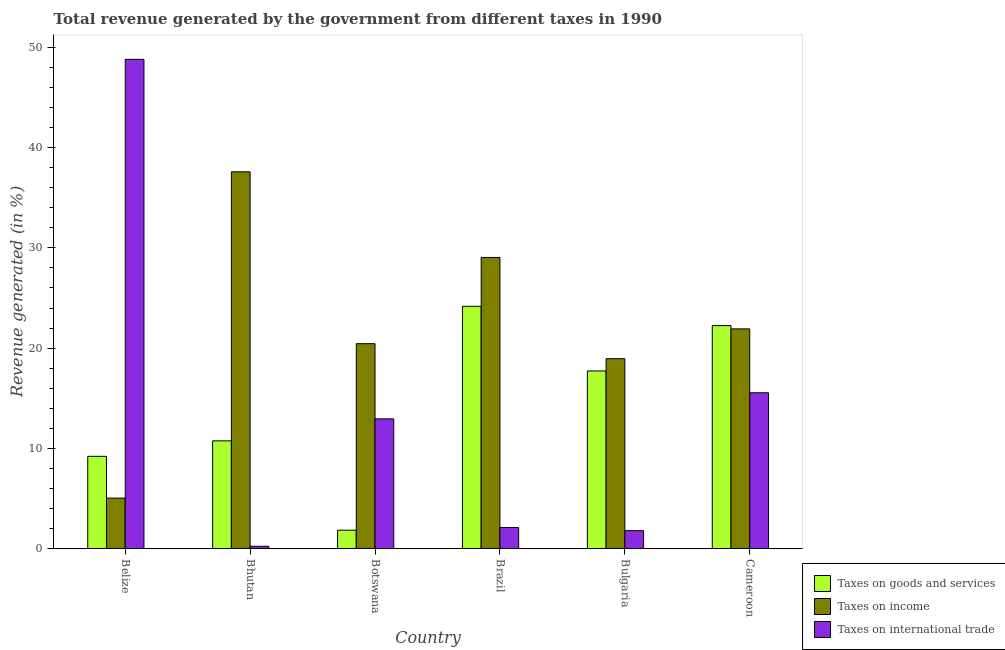How many groups of bars are there?
Offer a terse response. 6. Are the number of bars per tick equal to the number of legend labels?
Your answer should be very brief. Yes. Are the number of bars on each tick of the X-axis equal?
Keep it short and to the point. Yes. How many bars are there on the 2nd tick from the right?
Provide a short and direct response. 3. What is the label of the 4th group of bars from the left?
Provide a short and direct response. Brazil. What is the percentage of revenue generated by taxes on goods and services in Bhutan?
Give a very brief answer. 10.74. Across all countries, what is the maximum percentage of revenue generated by taxes on goods and services?
Offer a very short reply. 24.17. Across all countries, what is the minimum percentage of revenue generated by tax on international trade?
Make the answer very short. 0.22. In which country was the percentage of revenue generated by taxes on income minimum?
Offer a terse response. Belize. What is the total percentage of revenue generated by taxes on goods and services in the graph?
Give a very brief answer. 85.9. What is the difference between the percentage of revenue generated by taxes on income in Bhutan and that in Bulgaria?
Provide a short and direct response. 18.65. What is the difference between the percentage of revenue generated by taxes on income in Belize and the percentage of revenue generated by tax on international trade in Bhutan?
Offer a terse response. 4.81. What is the average percentage of revenue generated by taxes on income per country?
Provide a short and direct response. 22.16. What is the difference between the percentage of revenue generated by tax on international trade and percentage of revenue generated by taxes on goods and services in Botswana?
Keep it short and to the point. 11.11. In how many countries, is the percentage of revenue generated by taxes on income greater than 14 %?
Make the answer very short. 5. What is the ratio of the percentage of revenue generated by taxes on goods and services in Belize to that in Brazil?
Your response must be concise. 0.38. Is the percentage of revenue generated by tax on international trade in Belize less than that in Botswana?
Provide a succinct answer. No. What is the difference between the highest and the second highest percentage of revenue generated by taxes on income?
Provide a short and direct response. 8.55. What is the difference between the highest and the lowest percentage of revenue generated by tax on international trade?
Offer a terse response. 48.6. In how many countries, is the percentage of revenue generated by tax on international trade greater than the average percentage of revenue generated by tax on international trade taken over all countries?
Keep it short and to the point. 2. Is the sum of the percentage of revenue generated by taxes on income in Botswana and Cameroon greater than the maximum percentage of revenue generated by taxes on goods and services across all countries?
Offer a terse response. Yes. What does the 3rd bar from the left in Bhutan represents?
Keep it short and to the point. Taxes on international trade. What does the 2nd bar from the right in Botswana represents?
Make the answer very short. Taxes on income. Is it the case that in every country, the sum of the percentage of revenue generated by taxes on goods and services and percentage of revenue generated by taxes on income is greater than the percentage of revenue generated by tax on international trade?
Give a very brief answer. No. Are all the bars in the graph horizontal?
Your answer should be compact. No. How many countries are there in the graph?
Keep it short and to the point. 6. What is the difference between two consecutive major ticks on the Y-axis?
Offer a terse response. 10. Are the values on the major ticks of Y-axis written in scientific E-notation?
Your answer should be compact. No. Does the graph contain any zero values?
Make the answer very short. No. Does the graph contain grids?
Provide a short and direct response. No. Where does the legend appear in the graph?
Offer a terse response. Bottom right. What is the title of the graph?
Offer a very short reply. Total revenue generated by the government from different taxes in 1990. What is the label or title of the Y-axis?
Your response must be concise. Revenue generated (in %). What is the Revenue generated (in %) of Taxes on goods and services in Belize?
Keep it short and to the point. 9.2. What is the Revenue generated (in %) of Taxes on income in Belize?
Make the answer very short. 5.03. What is the Revenue generated (in %) of Taxes on international trade in Belize?
Your response must be concise. 48.82. What is the Revenue generated (in %) of Taxes on goods and services in Bhutan?
Offer a terse response. 10.74. What is the Revenue generated (in %) in Taxes on income in Bhutan?
Offer a very short reply. 37.59. What is the Revenue generated (in %) in Taxes on international trade in Bhutan?
Your answer should be compact. 0.22. What is the Revenue generated (in %) in Taxes on goods and services in Botswana?
Provide a succinct answer. 1.82. What is the Revenue generated (in %) of Taxes on income in Botswana?
Keep it short and to the point. 20.44. What is the Revenue generated (in %) of Taxes on international trade in Botswana?
Offer a terse response. 12.94. What is the Revenue generated (in %) of Taxes on goods and services in Brazil?
Offer a very short reply. 24.17. What is the Revenue generated (in %) in Taxes on income in Brazil?
Your answer should be compact. 29.05. What is the Revenue generated (in %) of Taxes on international trade in Brazil?
Make the answer very short. 2.09. What is the Revenue generated (in %) in Taxes on goods and services in Bulgaria?
Give a very brief answer. 17.72. What is the Revenue generated (in %) of Taxes on income in Bulgaria?
Ensure brevity in your answer.  18.94. What is the Revenue generated (in %) of Taxes on international trade in Bulgaria?
Give a very brief answer. 1.78. What is the Revenue generated (in %) of Taxes on goods and services in Cameroon?
Offer a terse response. 22.24. What is the Revenue generated (in %) of Taxes on income in Cameroon?
Make the answer very short. 21.92. What is the Revenue generated (in %) of Taxes on international trade in Cameroon?
Offer a terse response. 15.54. Across all countries, what is the maximum Revenue generated (in %) of Taxes on goods and services?
Your answer should be compact. 24.17. Across all countries, what is the maximum Revenue generated (in %) of Taxes on income?
Give a very brief answer. 37.59. Across all countries, what is the maximum Revenue generated (in %) of Taxes on international trade?
Give a very brief answer. 48.82. Across all countries, what is the minimum Revenue generated (in %) in Taxes on goods and services?
Ensure brevity in your answer.  1.82. Across all countries, what is the minimum Revenue generated (in %) of Taxes on income?
Provide a succinct answer. 5.03. Across all countries, what is the minimum Revenue generated (in %) in Taxes on international trade?
Make the answer very short. 0.22. What is the total Revenue generated (in %) of Taxes on goods and services in the graph?
Your response must be concise. 85.9. What is the total Revenue generated (in %) in Taxes on income in the graph?
Your answer should be compact. 132.97. What is the total Revenue generated (in %) in Taxes on international trade in the graph?
Offer a terse response. 81.39. What is the difference between the Revenue generated (in %) in Taxes on goods and services in Belize and that in Bhutan?
Give a very brief answer. -1.55. What is the difference between the Revenue generated (in %) in Taxes on income in Belize and that in Bhutan?
Your answer should be compact. -32.56. What is the difference between the Revenue generated (in %) of Taxes on international trade in Belize and that in Bhutan?
Your response must be concise. 48.6. What is the difference between the Revenue generated (in %) in Taxes on goods and services in Belize and that in Botswana?
Keep it short and to the point. 7.37. What is the difference between the Revenue generated (in %) in Taxes on income in Belize and that in Botswana?
Offer a very short reply. -15.41. What is the difference between the Revenue generated (in %) of Taxes on international trade in Belize and that in Botswana?
Give a very brief answer. 35.88. What is the difference between the Revenue generated (in %) of Taxes on goods and services in Belize and that in Brazil?
Offer a terse response. -14.97. What is the difference between the Revenue generated (in %) of Taxes on income in Belize and that in Brazil?
Keep it short and to the point. -24.02. What is the difference between the Revenue generated (in %) of Taxes on international trade in Belize and that in Brazil?
Your answer should be very brief. 46.73. What is the difference between the Revenue generated (in %) of Taxes on goods and services in Belize and that in Bulgaria?
Make the answer very short. -8.52. What is the difference between the Revenue generated (in %) of Taxes on income in Belize and that in Bulgaria?
Keep it short and to the point. -13.92. What is the difference between the Revenue generated (in %) in Taxes on international trade in Belize and that in Bulgaria?
Offer a terse response. 47.04. What is the difference between the Revenue generated (in %) in Taxes on goods and services in Belize and that in Cameroon?
Keep it short and to the point. -13.05. What is the difference between the Revenue generated (in %) in Taxes on income in Belize and that in Cameroon?
Your answer should be compact. -16.89. What is the difference between the Revenue generated (in %) of Taxes on international trade in Belize and that in Cameroon?
Your response must be concise. 33.28. What is the difference between the Revenue generated (in %) in Taxes on goods and services in Bhutan and that in Botswana?
Provide a short and direct response. 8.92. What is the difference between the Revenue generated (in %) in Taxes on income in Bhutan and that in Botswana?
Make the answer very short. 17.15. What is the difference between the Revenue generated (in %) of Taxes on international trade in Bhutan and that in Botswana?
Offer a very short reply. -12.72. What is the difference between the Revenue generated (in %) of Taxes on goods and services in Bhutan and that in Brazil?
Offer a terse response. -13.43. What is the difference between the Revenue generated (in %) in Taxes on income in Bhutan and that in Brazil?
Give a very brief answer. 8.55. What is the difference between the Revenue generated (in %) in Taxes on international trade in Bhutan and that in Brazil?
Make the answer very short. -1.87. What is the difference between the Revenue generated (in %) in Taxes on goods and services in Bhutan and that in Bulgaria?
Keep it short and to the point. -6.97. What is the difference between the Revenue generated (in %) in Taxes on income in Bhutan and that in Bulgaria?
Ensure brevity in your answer.  18.65. What is the difference between the Revenue generated (in %) of Taxes on international trade in Bhutan and that in Bulgaria?
Provide a succinct answer. -1.56. What is the difference between the Revenue generated (in %) in Taxes on goods and services in Bhutan and that in Cameroon?
Your answer should be compact. -11.5. What is the difference between the Revenue generated (in %) in Taxes on income in Bhutan and that in Cameroon?
Your answer should be compact. 15.68. What is the difference between the Revenue generated (in %) in Taxes on international trade in Bhutan and that in Cameroon?
Your response must be concise. -15.32. What is the difference between the Revenue generated (in %) in Taxes on goods and services in Botswana and that in Brazil?
Provide a succinct answer. -22.35. What is the difference between the Revenue generated (in %) of Taxes on income in Botswana and that in Brazil?
Keep it short and to the point. -8.61. What is the difference between the Revenue generated (in %) in Taxes on international trade in Botswana and that in Brazil?
Your answer should be very brief. 10.85. What is the difference between the Revenue generated (in %) of Taxes on goods and services in Botswana and that in Bulgaria?
Give a very brief answer. -15.89. What is the difference between the Revenue generated (in %) of Taxes on income in Botswana and that in Bulgaria?
Your response must be concise. 1.5. What is the difference between the Revenue generated (in %) in Taxes on international trade in Botswana and that in Bulgaria?
Provide a short and direct response. 11.16. What is the difference between the Revenue generated (in %) in Taxes on goods and services in Botswana and that in Cameroon?
Give a very brief answer. -20.42. What is the difference between the Revenue generated (in %) in Taxes on income in Botswana and that in Cameroon?
Provide a short and direct response. -1.48. What is the difference between the Revenue generated (in %) in Taxes on international trade in Botswana and that in Cameroon?
Provide a succinct answer. -2.61. What is the difference between the Revenue generated (in %) of Taxes on goods and services in Brazil and that in Bulgaria?
Provide a short and direct response. 6.45. What is the difference between the Revenue generated (in %) in Taxes on income in Brazil and that in Bulgaria?
Offer a very short reply. 10.1. What is the difference between the Revenue generated (in %) of Taxes on international trade in Brazil and that in Bulgaria?
Offer a very short reply. 0.31. What is the difference between the Revenue generated (in %) in Taxes on goods and services in Brazil and that in Cameroon?
Offer a terse response. 1.93. What is the difference between the Revenue generated (in %) of Taxes on income in Brazil and that in Cameroon?
Offer a very short reply. 7.13. What is the difference between the Revenue generated (in %) in Taxes on international trade in Brazil and that in Cameroon?
Make the answer very short. -13.45. What is the difference between the Revenue generated (in %) in Taxes on goods and services in Bulgaria and that in Cameroon?
Give a very brief answer. -4.53. What is the difference between the Revenue generated (in %) of Taxes on income in Bulgaria and that in Cameroon?
Give a very brief answer. -2.97. What is the difference between the Revenue generated (in %) of Taxes on international trade in Bulgaria and that in Cameroon?
Offer a very short reply. -13.76. What is the difference between the Revenue generated (in %) in Taxes on goods and services in Belize and the Revenue generated (in %) in Taxes on income in Bhutan?
Make the answer very short. -28.4. What is the difference between the Revenue generated (in %) of Taxes on goods and services in Belize and the Revenue generated (in %) of Taxes on international trade in Bhutan?
Keep it short and to the point. 8.98. What is the difference between the Revenue generated (in %) of Taxes on income in Belize and the Revenue generated (in %) of Taxes on international trade in Bhutan?
Ensure brevity in your answer.  4.81. What is the difference between the Revenue generated (in %) in Taxes on goods and services in Belize and the Revenue generated (in %) in Taxes on income in Botswana?
Provide a succinct answer. -11.24. What is the difference between the Revenue generated (in %) in Taxes on goods and services in Belize and the Revenue generated (in %) in Taxes on international trade in Botswana?
Ensure brevity in your answer.  -3.74. What is the difference between the Revenue generated (in %) of Taxes on income in Belize and the Revenue generated (in %) of Taxes on international trade in Botswana?
Make the answer very short. -7.91. What is the difference between the Revenue generated (in %) in Taxes on goods and services in Belize and the Revenue generated (in %) in Taxes on income in Brazil?
Your answer should be very brief. -19.85. What is the difference between the Revenue generated (in %) of Taxes on goods and services in Belize and the Revenue generated (in %) of Taxes on international trade in Brazil?
Your answer should be very brief. 7.11. What is the difference between the Revenue generated (in %) of Taxes on income in Belize and the Revenue generated (in %) of Taxes on international trade in Brazil?
Ensure brevity in your answer.  2.94. What is the difference between the Revenue generated (in %) in Taxes on goods and services in Belize and the Revenue generated (in %) in Taxes on income in Bulgaria?
Offer a terse response. -9.75. What is the difference between the Revenue generated (in %) of Taxes on goods and services in Belize and the Revenue generated (in %) of Taxes on international trade in Bulgaria?
Your answer should be very brief. 7.42. What is the difference between the Revenue generated (in %) in Taxes on income in Belize and the Revenue generated (in %) in Taxes on international trade in Bulgaria?
Make the answer very short. 3.25. What is the difference between the Revenue generated (in %) of Taxes on goods and services in Belize and the Revenue generated (in %) of Taxes on income in Cameroon?
Offer a terse response. -12.72. What is the difference between the Revenue generated (in %) of Taxes on goods and services in Belize and the Revenue generated (in %) of Taxes on international trade in Cameroon?
Your answer should be very brief. -6.35. What is the difference between the Revenue generated (in %) of Taxes on income in Belize and the Revenue generated (in %) of Taxes on international trade in Cameroon?
Offer a very short reply. -10.51. What is the difference between the Revenue generated (in %) of Taxes on goods and services in Bhutan and the Revenue generated (in %) of Taxes on income in Botswana?
Ensure brevity in your answer.  -9.7. What is the difference between the Revenue generated (in %) in Taxes on goods and services in Bhutan and the Revenue generated (in %) in Taxes on international trade in Botswana?
Make the answer very short. -2.19. What is the difference between the Revenue generated (in %) in Taxes on income in Bhutan and the Revenue generated (in %) in Taxes on international trade in Botswana?
Your answer should be compact. 24.66. What is the difference between the Revenue generated (in %) in Taxes on goods and services in Bhutan and the Revenue generated (in %) in Taxes on income in Brazil?
Ensure brevity in your answer.  -18.3. What is the difference between the Revenue generated (in %) of Taxes on goods and services in Bhutan and the Revenue generated (in %) of Taxes on international trade in Brazil?
Offer a terse response. 8.65. What is the difference between the Revenue generated (in %) of Taxes on income in Bhutan and the Revenue generated (in %) of Taxes on international trade in Brazil?
Your response must be concise. 35.5. What is the difference between the Revenue generated (in %) of Taxes on goods and services in Bhutan and the Revenue generated (in %) of Taxes on income in Bulgaria?
Offer a terse response. -8.2. What is the difference between the Revenue generated (in %) of Taxes on goods and services in Bhutan and the Revenue generated (in %) of Taxes on international trade in Bulgaria?
Offer a very short reply. 8.96. What is the difference between the Revenue generated (in %) of Taxes on income in Bhutan and the Revenue generated (in %) of Taxes on international trade in Bulgaria?
Your answer should be very brief. 35.82. What is the difference between the Revenue generated (in %) of Taxes on goods and services in Bhutan and the Revenue generated (in %) of Taxes on income in Cameroon?
Provide a succinct answer. -11.18. What is the difference between the Revenue generated (in %) of Taxes on goods and services in Bhutan and the Revenue generated (in %) of Taxes on international trade in Cameroon?
Give a very brief answer. -4.8. What is the difference between the Revenue generated (in %) of Taxes on income in Bhutan and the Revenue generated (in %) of Taxes on international trade in Cameroon?
Your response must be concise. 22.05. What is the difference between the Revenue generated (in %) of Taxes on goods and services in Botswana and the Revenue generated (in %) of Taxes on income in Brazil?
Make the answer very short. -27.22. What is the difference between the Revenue generated (in %) in Taxes on goods and services in Botswana and the Revenue generated (in %) in Taxes on international trade in Brazil?
Give a very brief answer. -0.27. What is the difference between the Revenue generated (in %) of Taxes on income in Botswana and the Revenue generated (in %) of Taxes on international trade in Brazil?
Keep it short and to the point. 18.35. What is the difference between the Revenue generated (in %) in Taxes on goods and services in Botswana and the Revenue generated (in %) in Taxes on income in Bulgaria?
Keep it short and to the point. -17.12. What is the difference between the Revenue generated (in %) in Taxes on goods and services in Botswana and the Revenue generated (in %) in Taxes on international trade in Bulgaria?
Keep it short and to the point. 0.05. What is the difference between the Revenue generated (in %) in Taxes on income in Botswana and the Revenue generated (in %) in Taxes on international trade in Bulgaria?
Your response must be concise. 18.66. What is the difference between the Revenue generated (in %) in Taxes on goods and services in Botswana and the Revenue generated (in %) in Taxes on income in Cameroon?
Make the answer very short. -20.09. What is the difference between the Revenue generated (in %) of Taxes on goods and services in Botswana and the Revenue generated (in %) of Taxes on international trade in Cameroon?
Give a very brief answer. -13.72. What is the difference between the Revenue generated (in %) of Taxes on income in Botswana and the Revenue generated (in %) of Taxes on international trade in Cameroon?
Your answer should be very brief. 4.9. What is the difference between the Revenue generated (in %) in Taxes on goods and services in Brazil and the Revenue generated (in %) in Taxes on income in Bulgaria?
Offer a very short reply. 5.23. What is the difference between the Revenue generated (in %) of Taxes on goods and services in Brazil and the Revenue generated (in %) of Taxes on international trade in Bulgaria?
Your response must be concise. 22.39. What is the difference between the Revenue generated (in %) in Taxes on income in Brazil and the Revenue generated (in %) in Taxes on international trade in Bulgaria?
Your response must be concise. 27.27. What is the difference between the Revenue generated (in %) of Taxes on goods and services in Brazil and the Revenue generated (in %) of Taxes on income in Cameroon?
Your response must be concise. 2.25. What is the difference between the Revenue generated (in %) of Taxes on goods and services in Brazil and the Revenue generated (in %) of Taxes on international trade in Cameroon?
Ensure brevity in your answer.  8.63. What is the difference between the Revenue generated (in %) in Taxes on income in Brazil and the Revenue generated (in %) in Taxes on international trade in Cameroon?
Your answer should be very brief. 13.51. What is the difference between the Revenue generated (in %) of Taxes on goods and services in Bulgaria and the Revenue generated (in %) of Taxes on income in Cameroon?
Offer a very short reply. -4.2. What is the difference between the Revenue generated (in %) of Taxes on goods and services in Bulgaria and the Revenue generated (in %) of Taxes on international trade in Cameroon?
Ensure brevity in your answer.  2.18. What is the difference between the Revenue generated (in %) in Taxes on income in Bulgaria and the Revenue generated (in %) in Taxes on international trade in Cameroon?
Provide a succinct answer. 3.4. What is the average Revenue generated (in %) of Taxes on goods and services per country?
Keep it short and to the point. 14.32. What is the average Revenue generated (in %) in Taxes on income per country?
Ensure brevity in your answer.  22.16. What is the average Revenue generated (in %) of Taxes on international trade per country?
Provide a succinct answer. 13.56. What is the difference between the Revenue generated (in %) in Taxes on goods and services and Revenue generated (in %) in Taxes on income in Belize?
Keep it short and to the point. 4.17. What is the difference between the Revenue generated (in %) in Taxes on goods and services and Revenue generated (in %) in Taxes on international trade in Belize?
Offer a terse response. -39.62. What is the difference between the Revenue generated (in %) in Taxes on income and Revenue generated (in %) in Taxes on international trade in Belize?
Your response must be concise. -43.79. What is the difference between the Revenue generated (in %) of Taxes on goods and services and Revenue generated (in %) of Taxes on income in Bhutan?
Your response must be concise. -26.85. What is the difference between the Revenue generated (in %) of Taxes on goods and services and Revenue generated (in %) of Taxes on international trade in Bhutan?
Your response must be concise. 10.52. What is the difference between the Revenue generated (in %) of Taxes on income and Revenue generated (in %) of Taxes on international trade in Bhutan?
Ensure brevity in your answer.  37.38. What is the difference between the Revenue generated (in %) of Taxes on goods and services and Revenue generated (in %) of Taxes on income in Botswana?
Give a very brief answer. -18.62. What is the difference between the Revenue generated (in %) of Taxes on goods and services and Revenue generated (in %) of Taxes on international trade in Botswana?
Your answer should be very brief. -11.11. What is the difference between the Revenue generated (in %) of Taxes on income and Revenue generated (in %) of Taxes on international trade in Botswana?
Your response must be concise. 7.5. What is the difference between the Revenue generated (in %) of Taxes on goods and services and Revenue generated (in %) of Taxes on income in Brazil?
Offer a very short reply. -4.88. What is the difference between the Revenue generated (in %) of Taxes on goods and services and Revenue generated (in %) of Taxes on international trade in Brazil?
Provide a short and direct response. 22.08. What is the difference between the Revenue generated (in %) of Taxes on income and Revenue generated (in %) of Taxes on international trade in Brazil?
Offer a very short reply. 26.96. What is the difference between the Revenue generated (in %) in Taxes on goods and services and Revenue generated (in %) in Taxes on income in Bulgaria?
Offer a very short reply. -1.23. What is the difference between the Revenue generated (in %) in Taxes on goods and services and Revenue generated (in %) in Taxes on international trade in Bulgaria?
Offer a terse response. 15.94. What is the difference between the Revenue generated (in %) in Taxes on income and Revenue generated (in %) in Taxes on international trade in Bulgaria?
Offer a terse response. 17.17. What is the difference between the Revenue generated (in %) in Taxes on goods and services and Revenue generated (in %) in Taxes on income in Cameroon?
Give a very brief answer. 0.33. What is the difference between the Revenue generated (in %) in Taxes on goods and services and Revenue generated (in %) in Taxes on international trade in Cameroon?
Offer a terse response. 6.7. What is the difference between the Revenue generated (in %) in Taxes on income and Revenue generated (in %) in Taxes on international trade in Cameroon?
Your answer should be very brief. 6.38. What is the ratio of the Revenue generated (in %) of Taxes on goods and services in Belize to that in Bhutan?
Offer a very short reply. 0.86. What is the ratio of the Revenue generated (in %) of Taxes on income in Belize to that in Bhutan?
Your answer should be very brief. 0.13. What is the ratio of the Revenue generated (in %) in Taxes on international trade in Belize to that in Bhutan?
Keep it short and to the point. 222.97. What is the ratio of the Revenue generated (in %) of Taxes on goods and services in Belize to that in Botswana?
Provide a succinct answer. 5.04. What is the ratio of the Revenue generated (in %) of Taxes on income in Belize to that in Botswana?
Your answer should be very brief. 0.25. What is the ratio of the Revenue generated (in %) in Taxes on international trade in Belize to that in Botswana?
Give a very brief answer. 3.77. What is the ratio of the Revenue generated (in %) in Taxes on goods and services in Belize to that in Brazil?
Keep it short and to the point. 0.38. What is the ratio of the Revenue generated (in %) of Taxes on income in Belize to that in Brazil?
Provide a succinct answer. 0.17. What is the ratio of the Revenue generated (in %) in Taxes on international trade in Belize to that in Brazil?
Your response must be concise. 23.34. What is the ratio of the Revenue generated (in %) in Taxes on goods and services in Belize to that in Bulgaria?
Your response must be concise. 0.52. What is the ratio of the Revenue generated (in %) of Taxes on income in Belize to that in Bulgaria?
Keep it short and to the point. 0.27. What is the ratio of the Revenue generated (in %) of Taxes on international trade in Belize to that in Bulgaria?
Offer a terse response. 27.45. What is the ratio of the Revenue generated (in %) in Taxes on goods and services in Belize to that in Cameroon?
Make the answer very short. 0.41. What is the ratio of the Revenue generated (in %) of Taxes on income in Belize to that in Cameroon?
Offer a very short reply. 0.23. What is the ratio of the Revenue generated (in %) in Taxes on international trade in Belize to that in Cameroon?
Your response must be concise. 3.14. What is the ratio of the Revenue generated (in %) of Taxes on goods and services in Bhutan to that in Botswana?
Your answer should be compact. 5.89. What is the ratio of the Revenue generated (in %) of Taxes on income in Bhutan to that in Botswana?
Keep it short and to the point. 1.84. What is the ratio of the Revenue generated (in %) in Taxes on international trade in Bhutan to that in Botswana?
Your response must be concise. 0.02. What is the ratio of the Revenue generated (in %) in Taxes on goods and services in Bhutan to that in Brazil?
Ensure brevity in your answer.  0.44. What is the ratio of the Revenue generated (in %) in Taxes on income in Bhutan to that in Brazil?
Provide a short and direct response. 1.29. What is the ratio of the Revenue generated (in %) in Taxes on international trade in Bhutan to that in Brazil?
Provide a succinct answer. 0.1. What is the ratio of the Revenue generated (in %) in Taxes on goods and services in Bhutan to that in Bulgaria?
Give a very brief answer. 0.61. What is the ratio of the Revenue generated (in %) of Taxes on income in Bhutan to that in Bulgaria?
Ensure brevity in your answer.  1.98. What is the ratio of the Revenue generated (in %) of Taxes on international trade in Bhutan to that in Bulgaria?
Make the answer very short. 0.12. What is the ratio of the Revenue generated (in %) in Taxes on goods and services in Bhutan to that in Cameroon?
Keep it short and to the point. 0.48. What is the ratio of the Revenue generated (in %) in Taxes on income in Bhutan to that in Cameroon?
Provide a short and direct response. 1.72. What is the ratio of the Revenue generated (in %) of Taxes on international trade in Bhutan to that in Cameroon?
Ensure brevity in your answer.  0.01. What is the ratio of the Revenue generated (in %) in Taxes on goods and services in Botswana to that in Brazil?
Your answer should be very brief. 0.08. What is the ratio of the Revenue generated (in %) of Taxes on income in Botswana to that in Brazil?
Offer a very short reply. 0.7. What is the ratio of the Revenue generated (in %) of Taxes on international trade in Botswana to that in Brazil?
Your answer should be compact. 6.19. What is the ratio of the Revenue generated (in %) of Taxes on goods and services in Botswana to that in Bulgaria?
Your answer should be very brief. 0.1. What is the ratio of the Revenue generated (in %) of Taxes on income in Botswana to that in Bulgaria?
Keep it short and to the point. 1.08. What is the ratio of the Revenue generated (in %) of Taxes on international trade in Botswana to that in Bulgaria?
Provide a short and direct response. 7.27. What is the ratio of the Revenue generated (in %) of Taxes on goods and services in Botswana to that in Cameroon?
Ensure brevity in your answer.  0.08. What is the ratio of the Revenue generated (in %) in Taxes on income in Botswana to that in Cameroon?
Your answer should be very brief. 0.93. What is the ratio of the Revenue generated (in %) of Taxes on international trade in Botswana to that in Cameroon?
Provide a succinct answer. 0.83. What is the ratio of the Revenue generated (in %) of Taxes on goods and services in Brazil to that in Bulgaria?
Make the answer very short. 1.36. What is the ratio of the Revenue generated (in %) in Taxes on income in Brazil to that in Bulgaria?
Give a very brief answer. 1.53. What is the ratio of the Revenue generated (in %) in Taxes on international trade in Brazil to that in Bulgaria?
Provide a short and direct response. 1.18. What is the ratio of the Revenue generated (in %) of Taxes on goods and services in Brazil to that in Cameroon?
Offer a terse response. 1.09. What is the ratio of the Revenue generated (in %) in Taxes on income in Brazil to that in Cameroon?
Provide a short and direct response. 1.33. What is the ratio of the Revenue generated (in %) in Taxes on international trade in Brazil to that in Cameroon?
Keep it short and to the point. 0.13. What is the ratio of the Revenue generated (in %) of Taxes on goods and services in Bulgaria to that in Cameroon?
Make the answer very short. 0.8. What is the ratio of the Revenue generated (in %) in Taxes on income in Bulgaria to that in Cameroon?
Ensure brevity in your answer.  0.86. What is the ratio of the Revenue generated (in %) in Taxes on international trade in Bulgaria to that in Cameroon?
Offer a very short reply. 0.11. What is the difference between the highest and the second highest Revenue generated (in %) in Taxes on goods and services?
Provide a succinct answer. 1.93. What is the difference between the highest and the second highest Revenue generated (in %) of Taxes on income?
Offer a very short reply. 8.55. What is the difference between the highest and the second highest Revenue generated (in %) of Taxes on international trade?
Your answer should be very brief. 33.28. What is the difference between the highest and the lowest Revenue generated (in %) of Taxes on goods and services?
Give a very brief answer. 22.35. What is the difference between the highest and the lowest Revenue generated (in %) in Taxes on income?
Offer a terse response. 32.56. What is the difference between the highest and the lowest Revenue generated (in %) of Taxes on international trade?
Give a very brief answer. 48.6. 